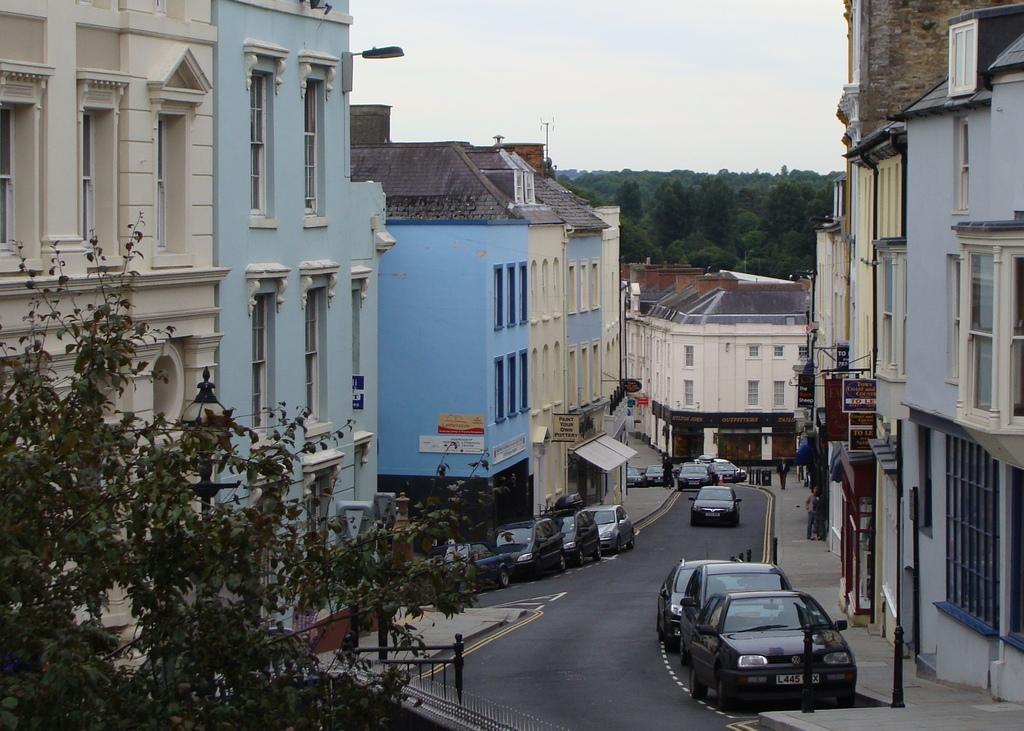What is located at the bottom of the image? There are cars and a road at the bottom of the image. What can be seen on the right side of the image? There are buildings and trees on the right side of the image. What is visible on the left side of the image? There are buildings, windows, and light on the left side of the image. What is visible in the background of the image? The sky is visible in the image. What type of rod is being used to hang the linen in the image? There is no rod or linen present in the image. What need is being fulfilled by the cars in the image? The cars in the image are not fulfilling any specific need; they are simply part of the scene. 